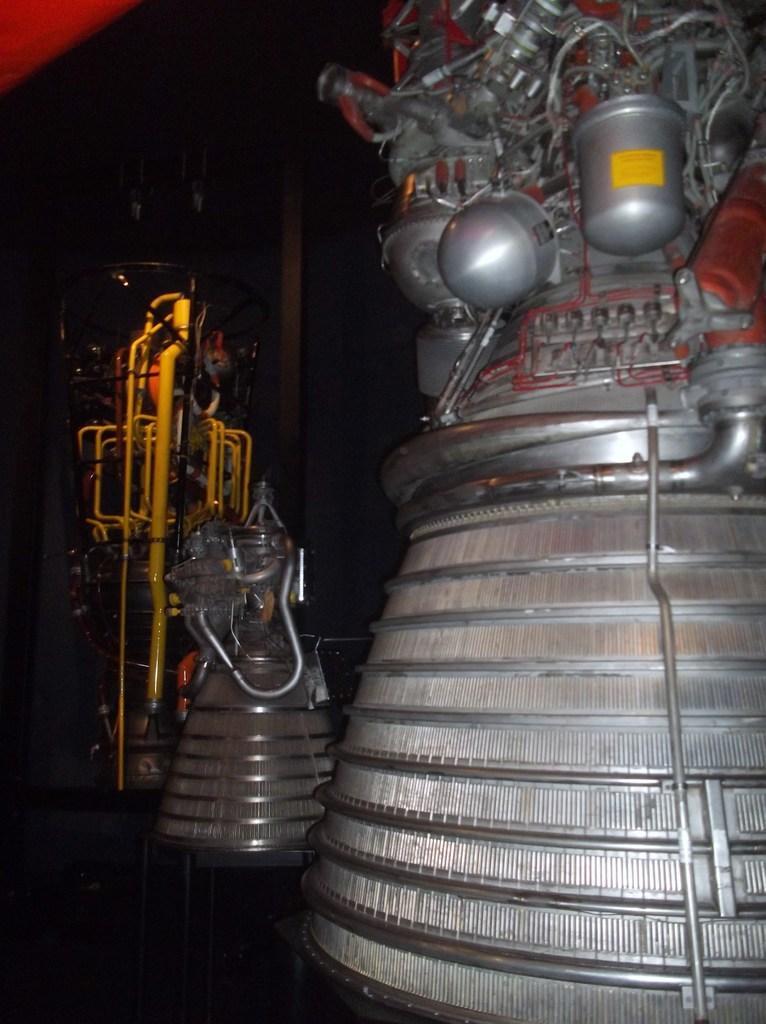Describe this image in one or two sentences. In this image, we can see some metallic objects. We can also see a yellow colored object and the wall. 